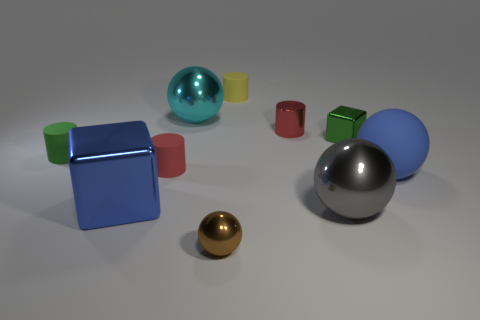What number of cylinders are there?
Your response must be concise. 4. There is a green object that is on the left side of the big cyan sphere; is its size the same as the green cube that is behind the large blue rubber thing?
Give a very brief answer. Yes. There is another metal thing that is the same shape as the tiny yellow object; what is its color?
Provide a short and direct response. Red. Is the shape of the small green metal thing the same as the blue metallic thing?
Make the answer very short. Yes. There is a cyan shiny thing that is the same shape as the blue matte object; what size is it?
Make the answer very short. Large. What number of big gray balls have the same material as the gray object?
Your answer should be compact. 0. What number of things are either red metallic spheres or large blue objects?
Provide a short and direct response. 2. Is there a tiny yellow rubber thing that is behind the tiny block in front of the large cyan shiny sphere?
Offer a terse response. Yes. Is the number of cubes that are behind the blue shiny object greater than the number of small yellow things that are right of the yellow object?
Your answer should be very brief. Yes. There is another small cylinder that is the same color as the shiny cylinder; what material is it?
Your response must be concise. Rubber. 